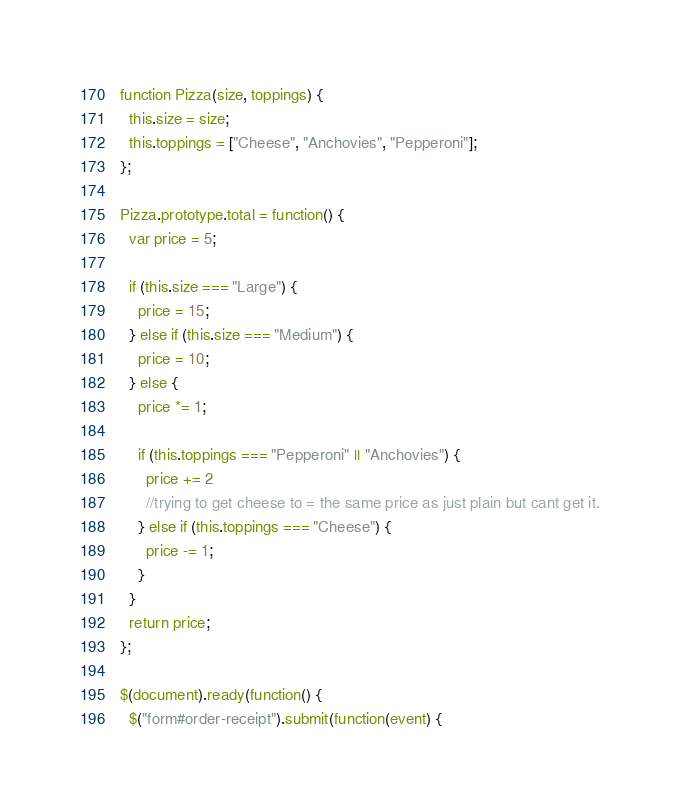<code> <loc_0><loc_0><loc_500><loc_500><_JavaScript_>function Pizza(size, toppings) {
  this.size = size;
  this.toppings = ["Cheese", "Anchovies", "Pepperoni"];
};

Pizza.prototype.total = function() {
  var price = 5;

  if (this.size === "Large") {
    price = 15;
  } else if (this.size === "Medium") {
    price = 10;
  } else {
    price *= 1;

    if (this.toppings === "Pepperoni" || "Anchovies") {
      price += 2
      //trying to get cheese to = the same price as just plain but cant get it.
    } else if (this.toppings === "Cheese") {
      price -= 1;
    }
  }
  return price;
};

$(document).ready(function() {
  $("form#order-receipt").submit(function(event) {</code> 